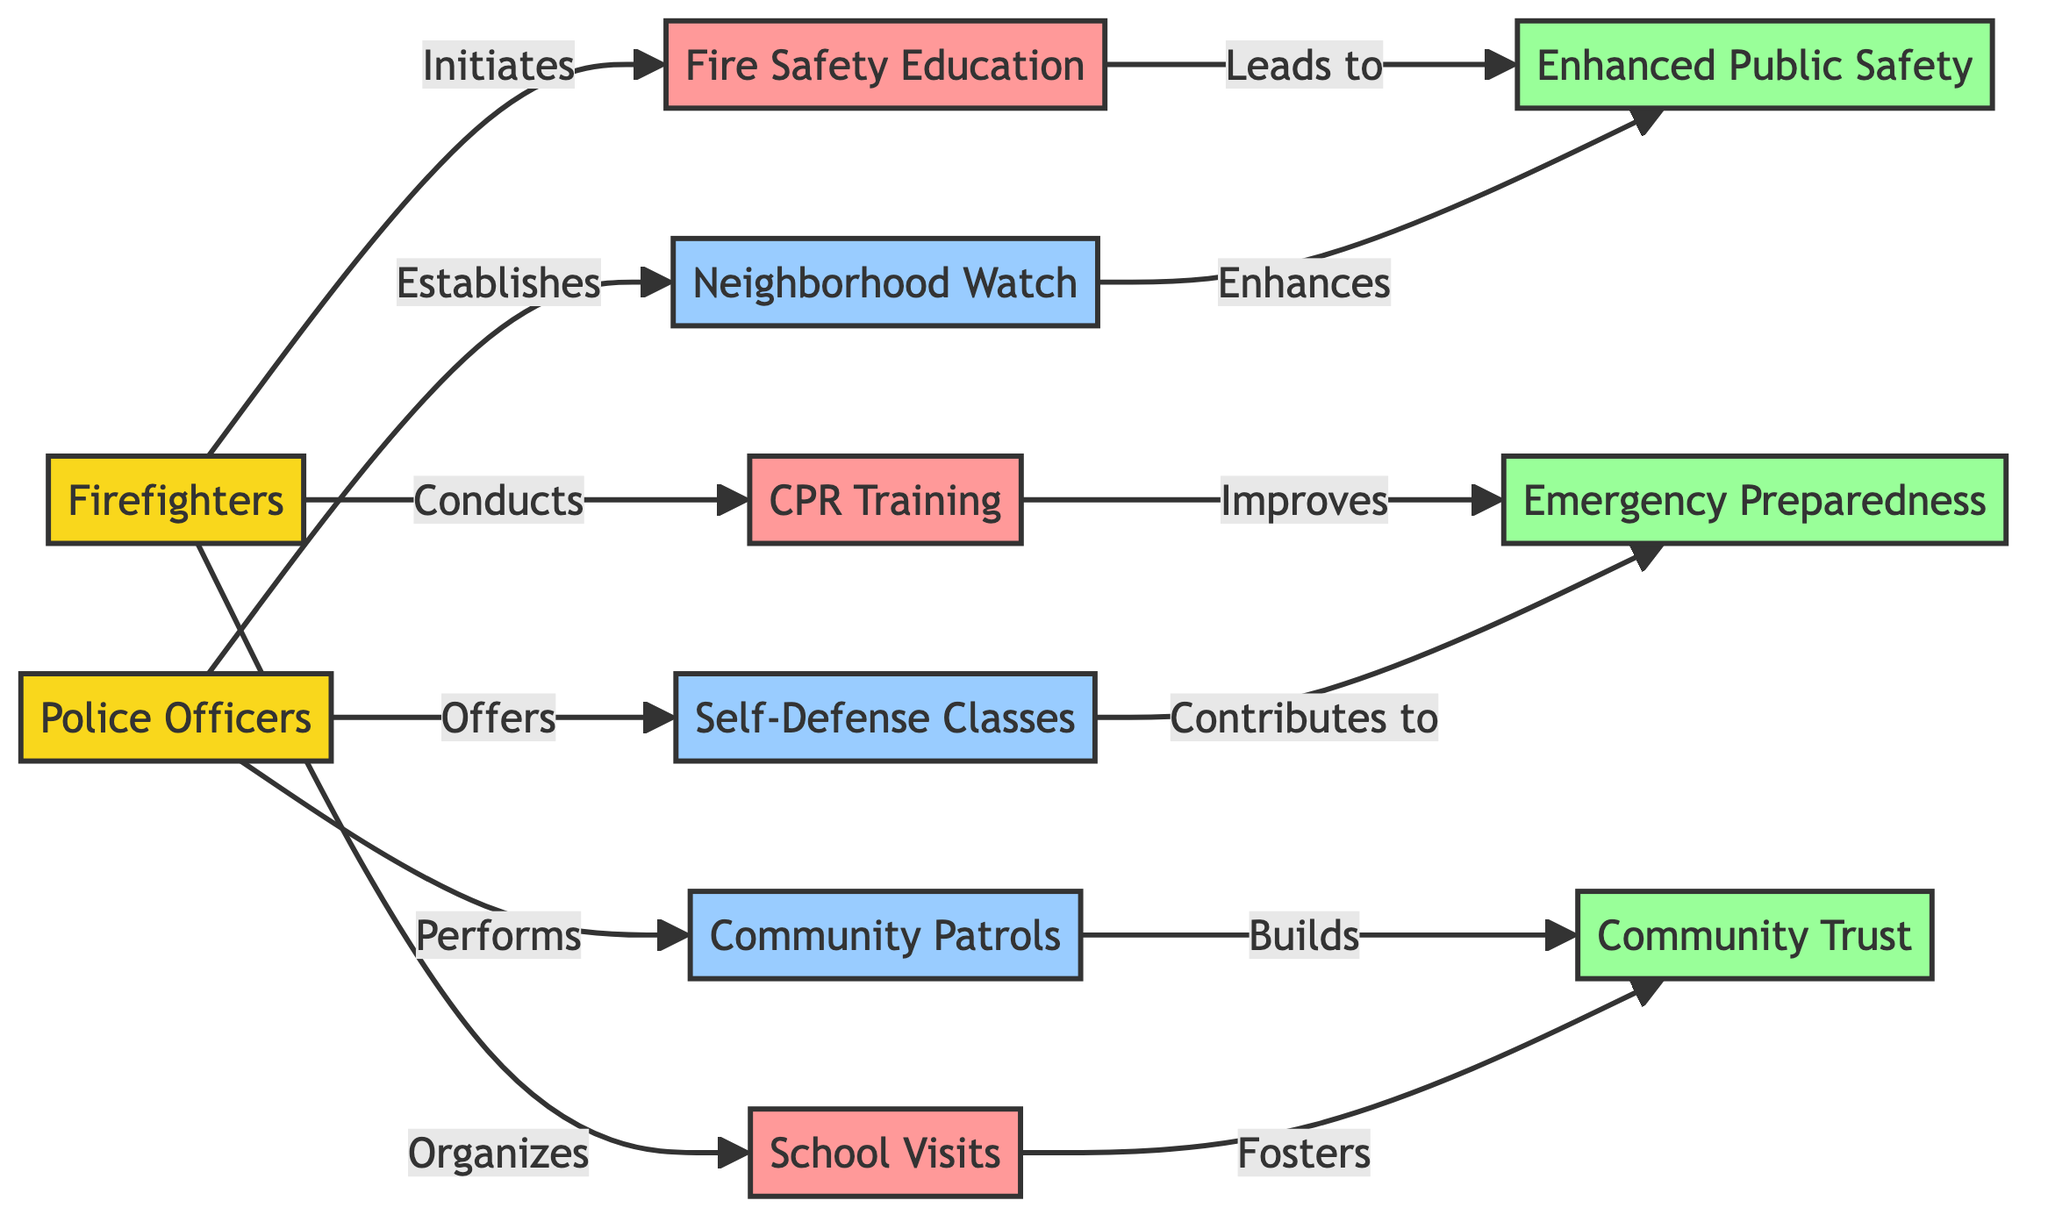What are the three community outreach initiatives by firefighters? The diagram lists three initiatives specifically associated with firefighters: Fire Safety Education, CPR Training, and School Visits. These are directly connected to the "Firefighters" node.
Answer: Fire Safety Education, CPR Training, School Visits How many initiatives are associated with police officers? There are three initiatives stemming from the police officers' node: Community Patrols, Neighborhood Watch Programs, and Self-Defense Classes. This is determined by counting the edges connecting the "Police Officers" node to its respective initiatives.
Answer: 3 Which initiative leads to "Enhanced Public Safety"? The "Enhanced Public Safety" outcome is linked to two initiatives: Fire Safety Education and Neighborhood Watch Programs, as evidenced by the edges extending from these nodes to the "Enhanced Public Safety" node.
Answer: Fire Safety Education, Neighborhood Watch Programs What impact does "CPR Training" improve? The initiative of "CPR Training" is linked to the impact of "Emergency Preparedness" in the diagram, showing a direct relationship between training in CPR and the enhancement of emergency readiness.
Answer: Emergency Preparedness Which profession organizes "School Visits"? The "School Visits" initiative is connected to the "Firefighters" node, indicating that firefighters are responsible for organizing this outreach program.
Answer: Firefighters Which initiative builds "Community Trust"? "Community Trust" is built through the initiative "Community Patrols" as indicated by the connection of this initiative to the respective impact node.
Answer: Community Patrols How many total nodes are represented in this diagram? The total number of nodes is represented by both professions, their initiatives, and the impact nodes, which totals to eleven nodes in the diagram. This is derived from counting all nodes listed.
Answer: 11 What is the relationship type between "Self-Defense Classes" and "Emergency Preparedness"? The relationship between "Self-Defense Classes" and "Emergency Preparedness" is that it contributes to it, showing a positive influence from this police initiative towards overall emergency readiness.
Answer: Contributes to Which two impacts relate to the "Neighborhood Watch Programs"? The "Neighborhood Watch Programs" initiative is related to the impacts of "Enhanced Public Safety" and "Community Trust." The diagram demonstrates these connections via edges extending from the initiative node to the respective impact nodes.
Answer: Enhanced Public Safety, Community Trust 